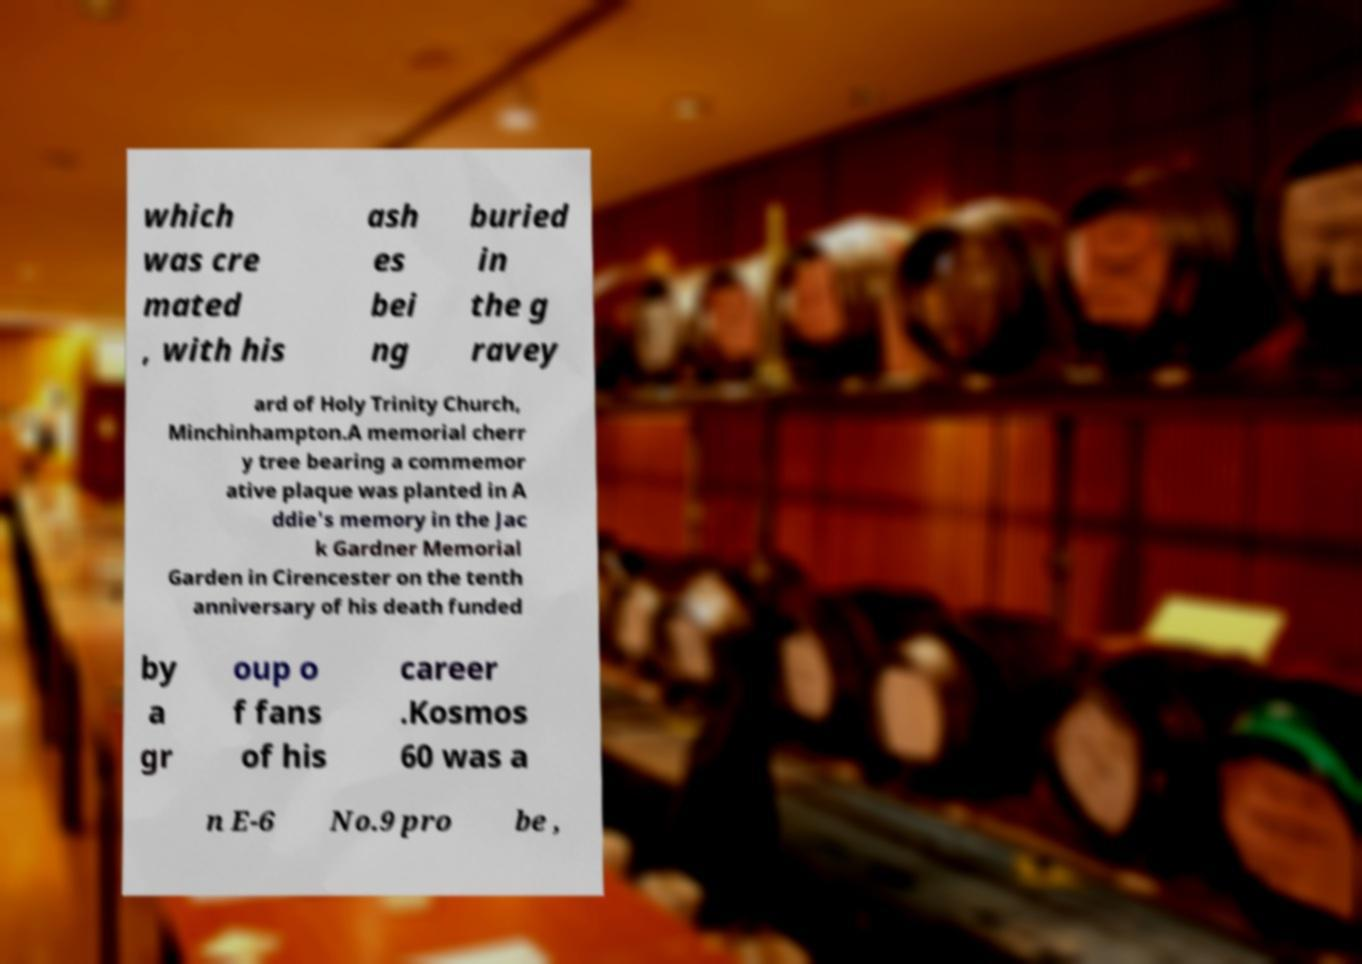There's text embedded in this image that I need extracted. Can you transcribe it verbatim? which was cre mated , with his ash es bei ng buried in the g ravey ard of Holy Trinity Church, Minchinhampton.A memorial cherr y tree bearing a commemor ative plaque was planted in A ddie's memory in the Jac k Gardner Memorial Garden in Cirencester on the tenth anniversary of his death funded by a gr oup o f fans of his career .Kosmos 60 was a n E-6 No.9 pro be , 